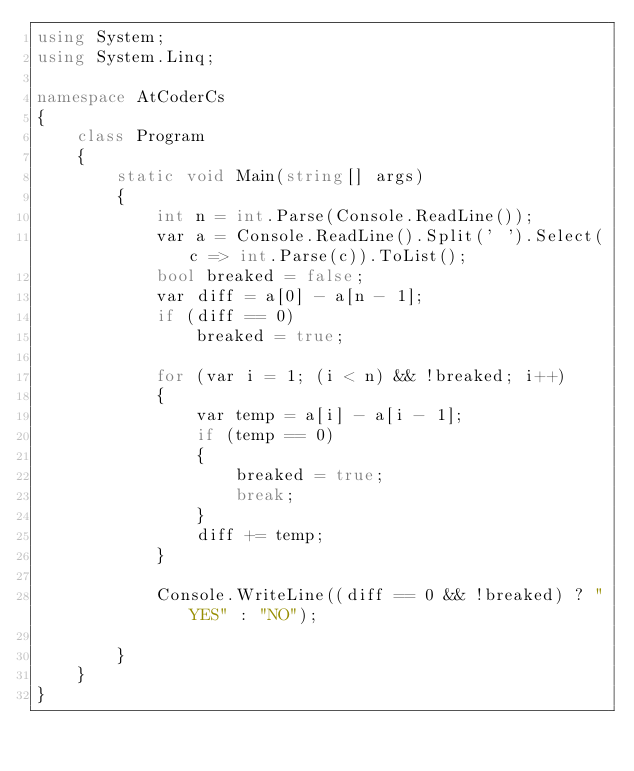<code> <loc_0><loc_0><loc_500><loc_500><_C#_>using System;
using System.Linq;

namespace AtCoderCs
{
    class Program
    {
        static void Main(string[] args)
        {
            int n = int.Parse(Console.ReadLine());
            var a = Console.ReadLine().Split(' ').Select(c => int.Parse(c)).ToList();
            bool breaked = false;
            var diff = a[0] - a[n - 1];
            if (diff == 0)
                breaked = true;

            for (var i = 1; (i < n) && !breaked; i++)
            {
                var temp = a[i] - a[i - 1];
                if (temp == 0)
                {
                    breaked = true;
                    break;
                }
                diff += temp;
            }

            Console.WriteLine((diff == 0 && !breaked) ? "YES" : "NO");

        }
    }
}
</code> 